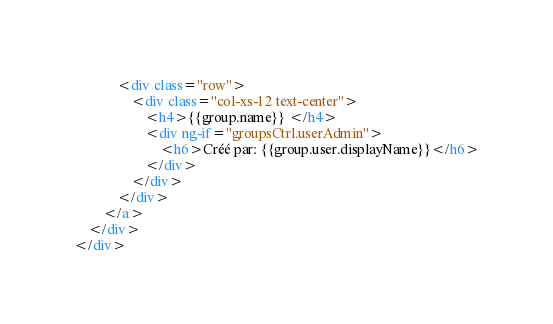<code> <loc_0><loc_0><loc_500><loc_500><_HTML_>            <div class="row">
                <div class="col-xs-12 text-center">
                    <h4>{{group.name}} </h4>
                    <div ng-if="groupsCtrl.userAdmin">
                        <h6>Créé par: {{group.user.displayName}}</h6>
                    </div>
                </div>
            </div>
        </a>
    </div>
</div></code> 